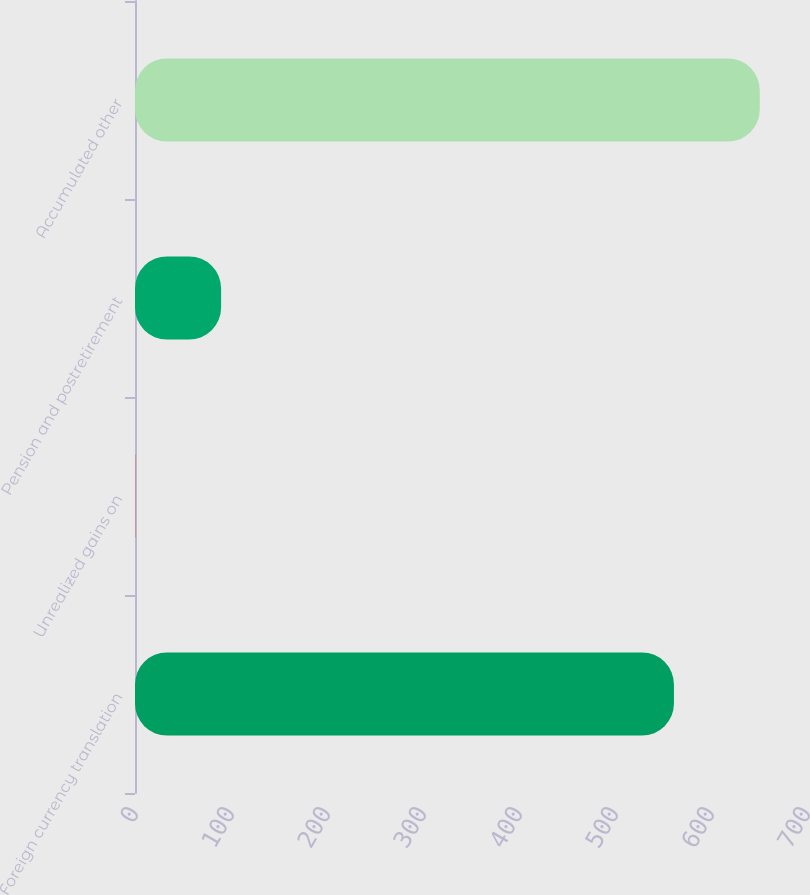Convert chart. <chart><loc_0><loc_0><loc_500><loc_500><bar_chart><fcel>Foreign currency translation<fcel>Unrealized gains on<fcel>Pension and postretirement<fcel>Accumulated other<nl><fcel>561.4<fcel>0.3<fcel>89.7<fcel>650.8<nl></chart> 